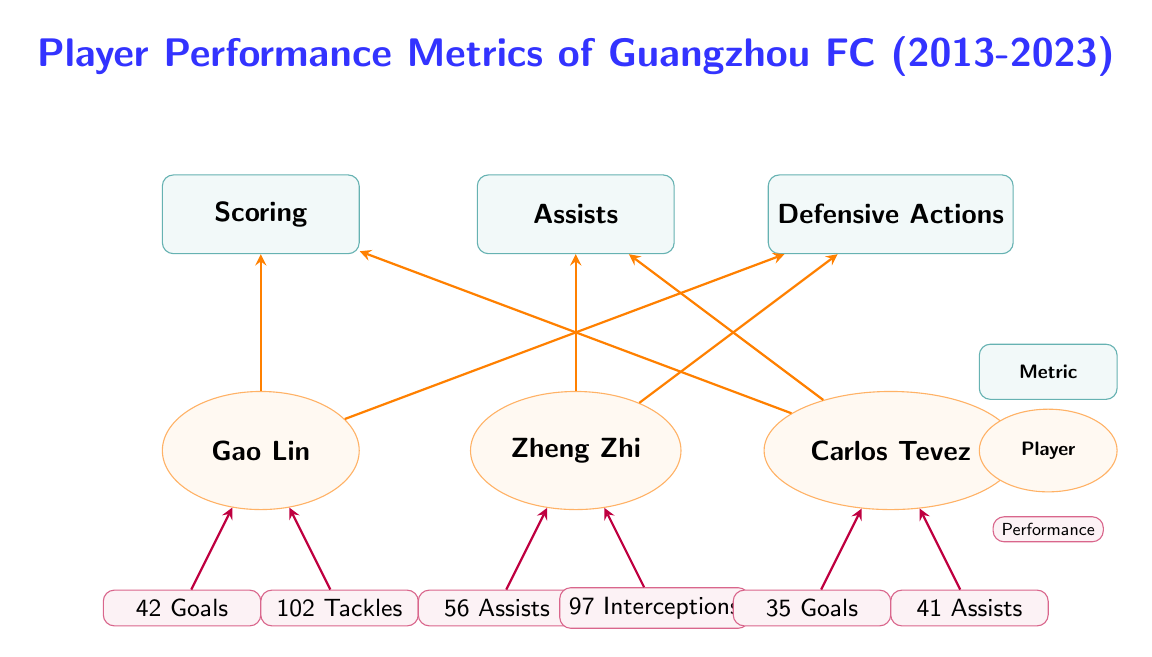What are the total goals scored by Gao Lin? The diagram shows that in the performance metrics linked to Gao Lin, the number of goals is specified as 42 Goals connected with the scoring metric.
Answer: 42 Goals How many assists did Zheng Zhi achieve? The performance metric related to Zheng Zhi indicates that he has provided 56 Assists, which is directly linked to the assists metric.
Answer: 56 Assists Which player had the highest number of defensive actions? To determine who had the highest defensive actions, we can compare the numbers: Gao Lin has 102 Tackles, Zheng Zhi has 97 Interceptions, and Carlos Tevez's defensive actions are not specified. Thus, Gao Lin has the highest with 102.
Answer: Gao Lin How many assists did Carlos Tevez register? The diagram denotes that Carlos Tevez is associated with 41 Assists under the assists metric.
Answer: 41 Assists What type of action is linked to Zheng Zhi's performance besides assists? The diagram indicates that Zheng Zhi is connected to the defensive actions metric as well, specifically showing 97 Interceptions.
Answer: Defensive Actions Which player is associated with scoring metrics in the diagram? Analyzing the connections reveals that both Gao Lin and Carlos Tevez are connected to the scoring metric, indicating their scoring contributions.
Answer: Gao Lin and Carlos Tevez How many total players are represented in the diagram? The diagram has three players displayed: Gao Lin, Zheng Zhi, and Carlos Tevez. Therefore, the total number of players is three.
Answer: 3 Which metric is linked to both Gao Lin and Tevez in their performances? The metric that connects both players is scoring, as both Gao Lin and Carlos Tevez have connections directed towards the scoring metric.
Answer: Scoring What is the total number of performance metrics illustrated in the diagram? The diagram includes three distinct performance metrics: Scoring, Assists, and Defensive Actions, making the total three.
Answer: 3 